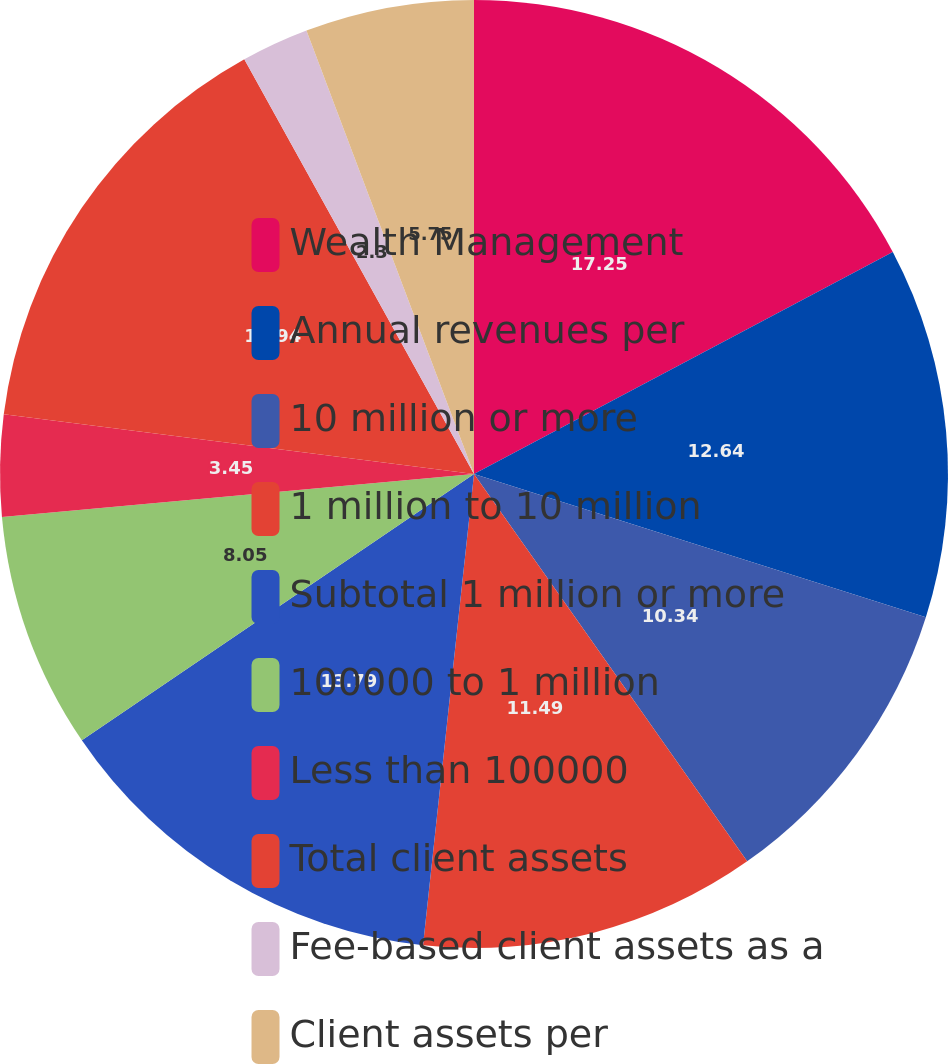<chart> <loc_0><loc_0><loc_500><loc_500><pie_chart><fcel>Wealth Management<fcel>Annual revenues per<fcel>10 million or more<fcel>1 million to 10 million<fcel>Subtotal 1 million or more<fcel>100000 to 1 million<fcel>Less than 100000<fcel>Total client assets<fcel>Fee-based client assets as a<fcel>Client assets per<nl><fcel>17.24%<fcel>12.64%<fcel>10.34%<fcel>11.49%<fcel>13.79%<fcel>8.05%<fcel>3.45%<fcel>14.94%<fcel>2.3%<fcel>5.75%<nl></chart> 